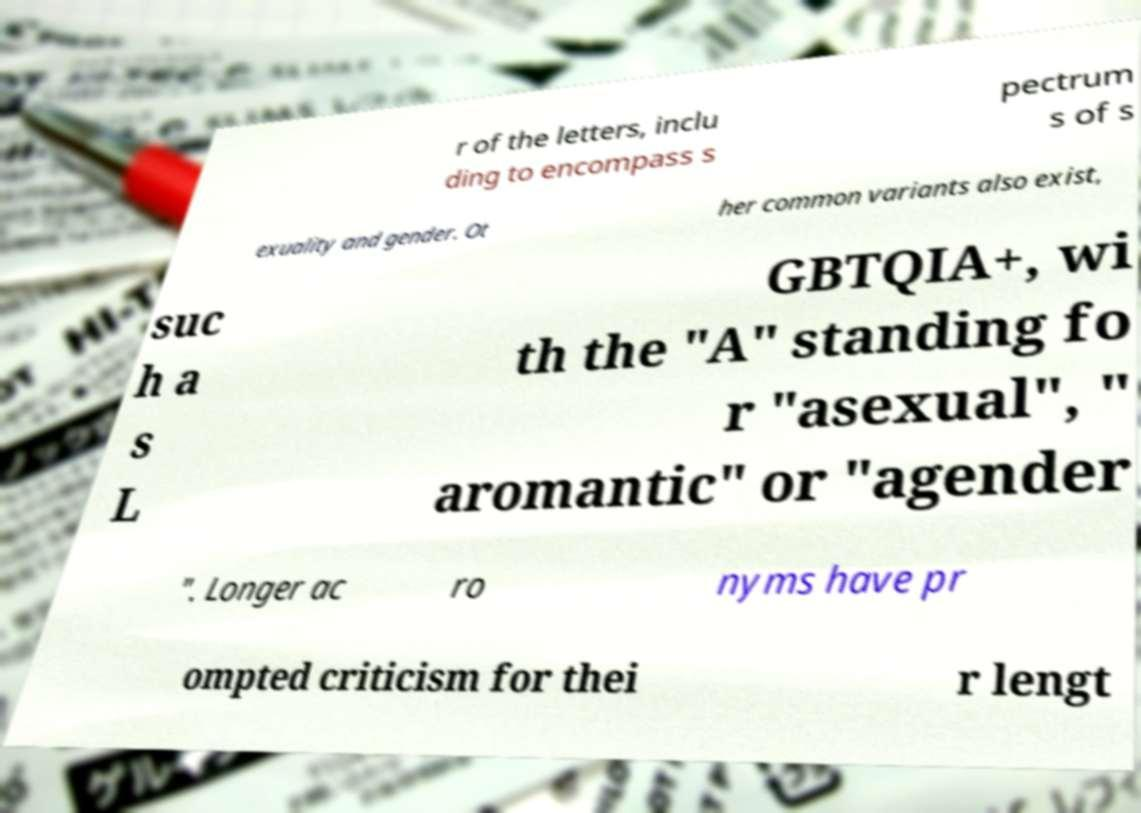Please read and relay the text visible in this image. What does it say? r of the letters, inclu ding to encompass s pectrum s of s exuality and gender. Ot her common variants also exist, suc h a s L GBTQIA+, wi th the "A" standing fo r "asexual", " aromantic" or "agender ". Longer ac ro nyms have pr ompted criticism for thei r lengt 